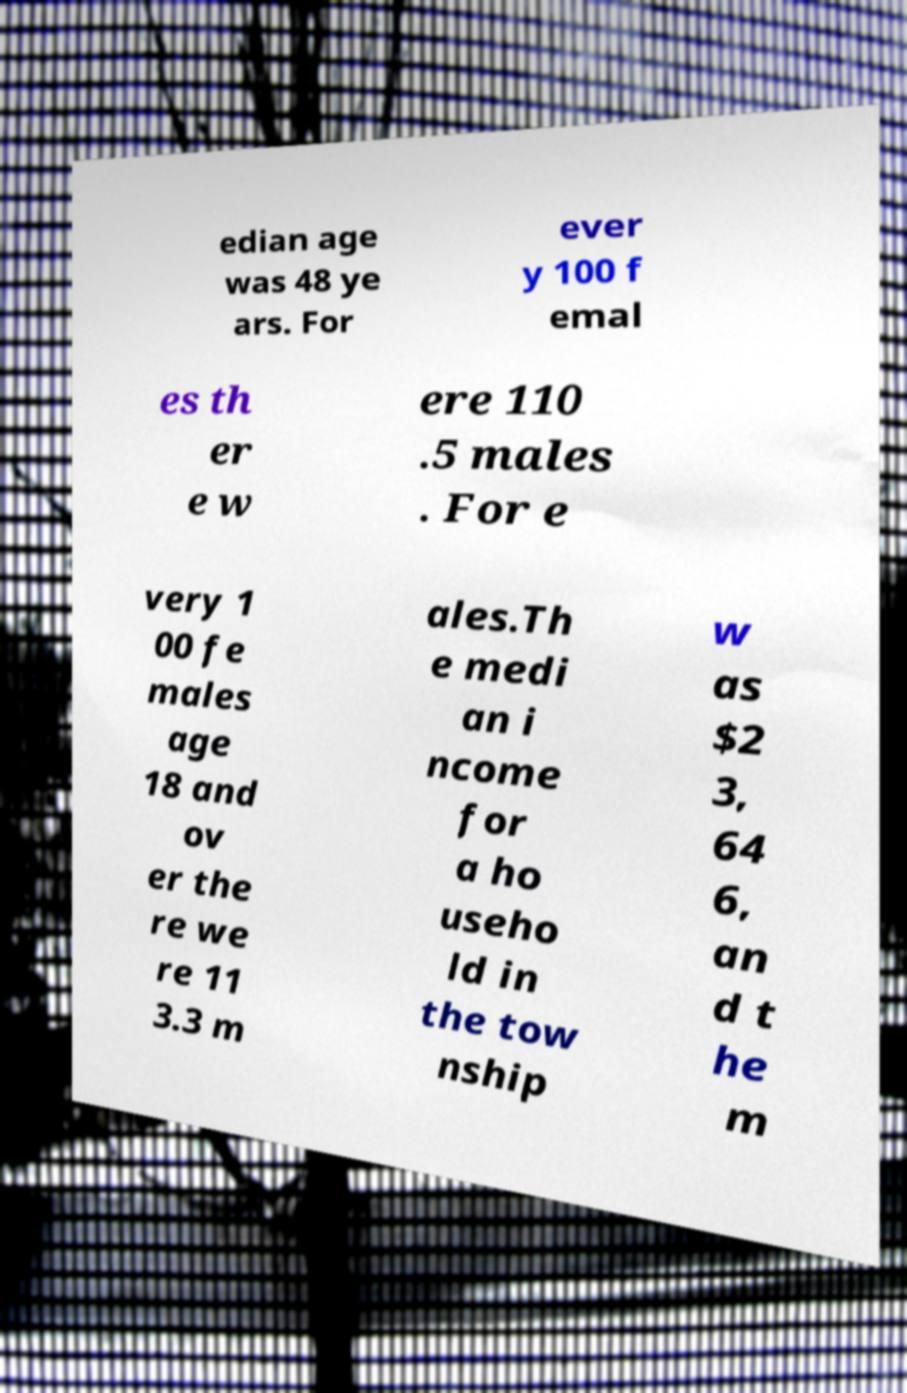Could you assist in decoding the text presented in this image and type it out clearly? edian age was 48 ye ars. For ever y 100 f emal es th er e w ere 110 .5 males . For e very 1 00 fe males age 18 and ov er the re we re 11 3.3 m ales.Th e medi an i ncome for a ho useho ld in the tow nship w as $2 3, 64 6, an d t he m 